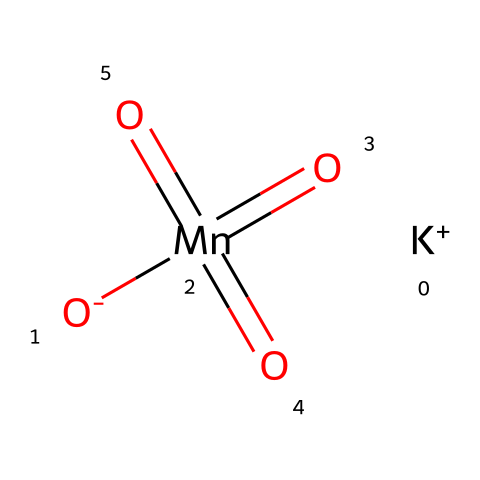what is the chemical name of this compound? The SMILES representation provided, [K+].[O-][Mn](=O)(=O)=O, corresponds to potassium permanganate, a well-known oxidizing agent.
Answer: potassium permanganate how many oxygen atoms are present in the structure? In the given structure, there are four oxygen atoms in total: one is negatively charged, and three are double bonded to the manganese atom (Mn).
Answer: four what is the oxidation state of manganese in this compound? Manganese in potassium permanganate has an oxidation state of +7. This is determined by the fact that Mn is bonded to four oxygen atoms, which typically have a -2 charge each; thus, the total charge from oxygen is -8, leading the manganese to have a +7 charge to balance it with the K+ ion.
Answer: +7 how is potassium permanganate classified in terms of its chemical properties? Potassium permanganate is classified as an oxidizer due to its ability to accept electrons in chemical reactions, particularly in redox reactions. This classification is supported by its high oxidation state and its reactivity with various substances.
Answer: oxidizer what role does potassium permanganate play in water purification? Potassium permanganate serves as an oxidizing agent in water purification processes, helping to oxidize impurities and kill bacteria. The oxidizing action is attributed to the high oxidation state of manganese, which facilitates the breakdown of contaminants.
Answer: oxidizing agent how many bonds does manganese form in this compound? Manganese in potassium permanganate forms four total bonds: one with the negatively charged oxygen atom, and three double bonds with the other oxygen atoms.
Answer: four 